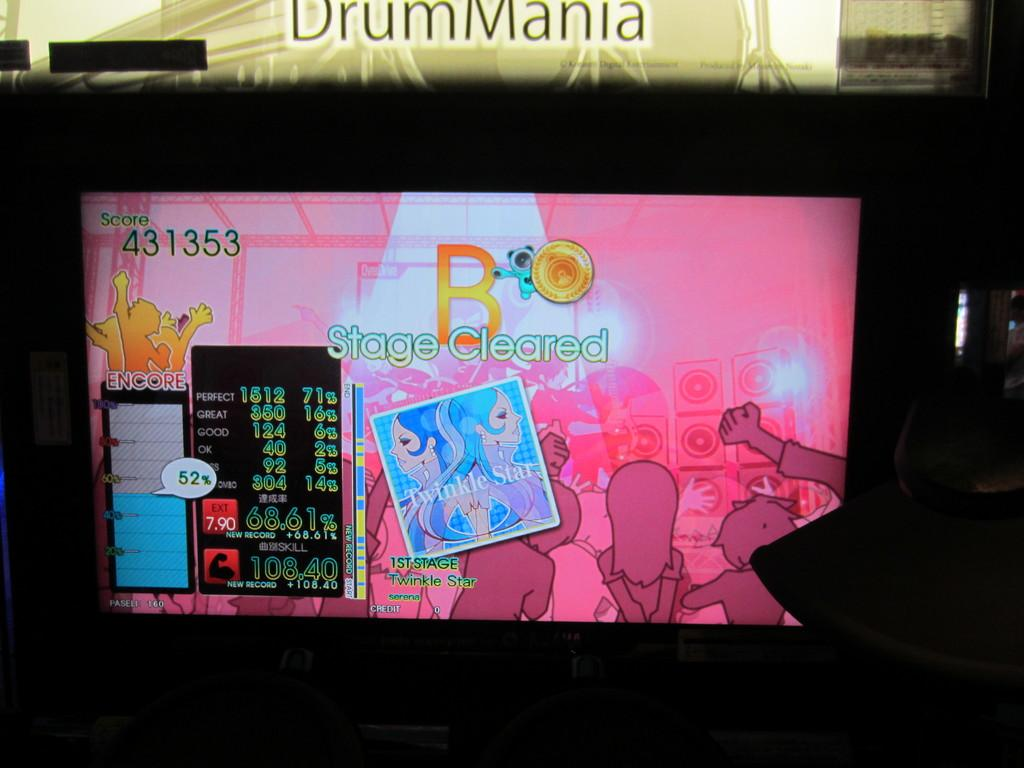<image>
Write a terse but informative summary of the picture. A monitor has a screen with a pink background and "stage cleared" in the middle of the screen. 